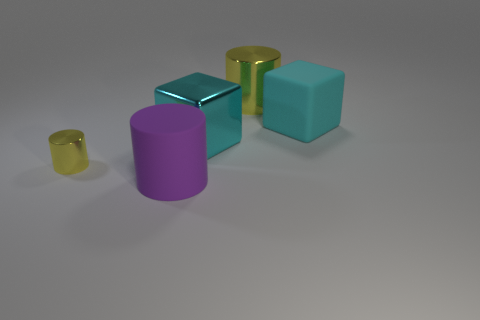There is a big cylinder behind the cyan metallic thing; does it have the same color as the big rubber object left of the large metallic cube? No, the colors are not the same. The big cylinder behind the cyan metallic object is purple and has a matte finish. In contrast, the big rubber object placed to the left of the large metallic cube is cyan and appears to have a more muted, matte texture. 